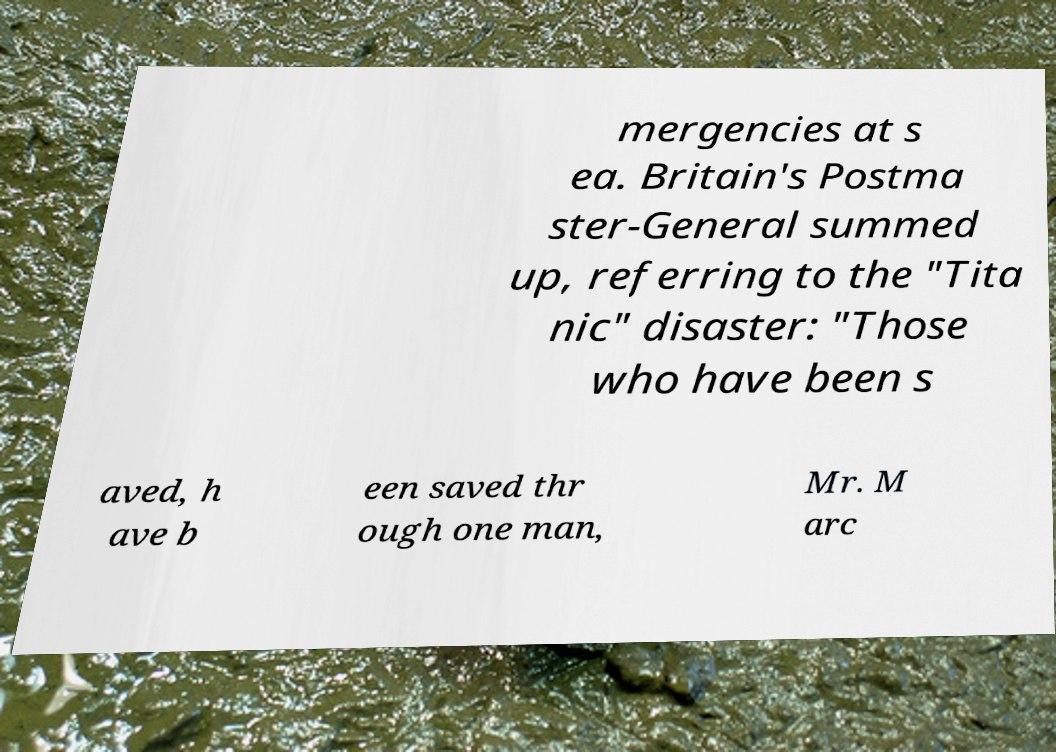I need the written content from this picture converted into text. Can you do that? mergencies at s ea. Britain's Postma ster-General summed up, referring to the "Tita nic" disaster: "Those who have been s aved, h ave b een saved thr ough one man, Mr. M arc 